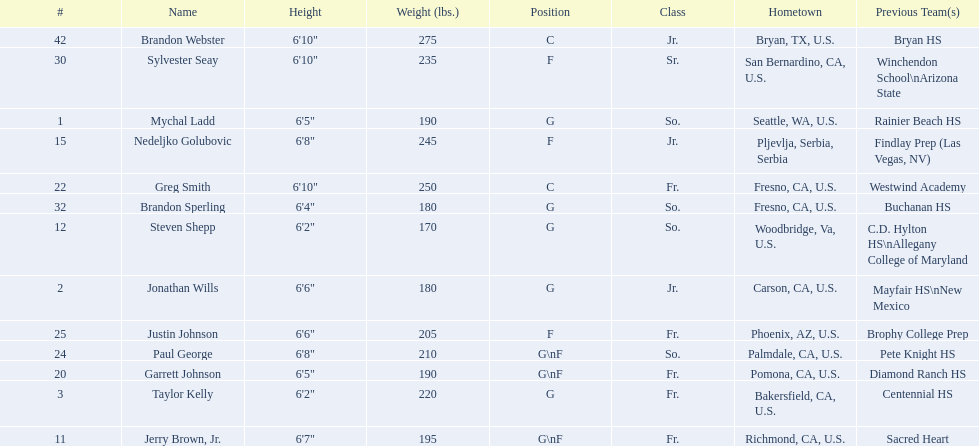Who is the next heaviest player after nedelijko golubovic? Sylvester Seay. 